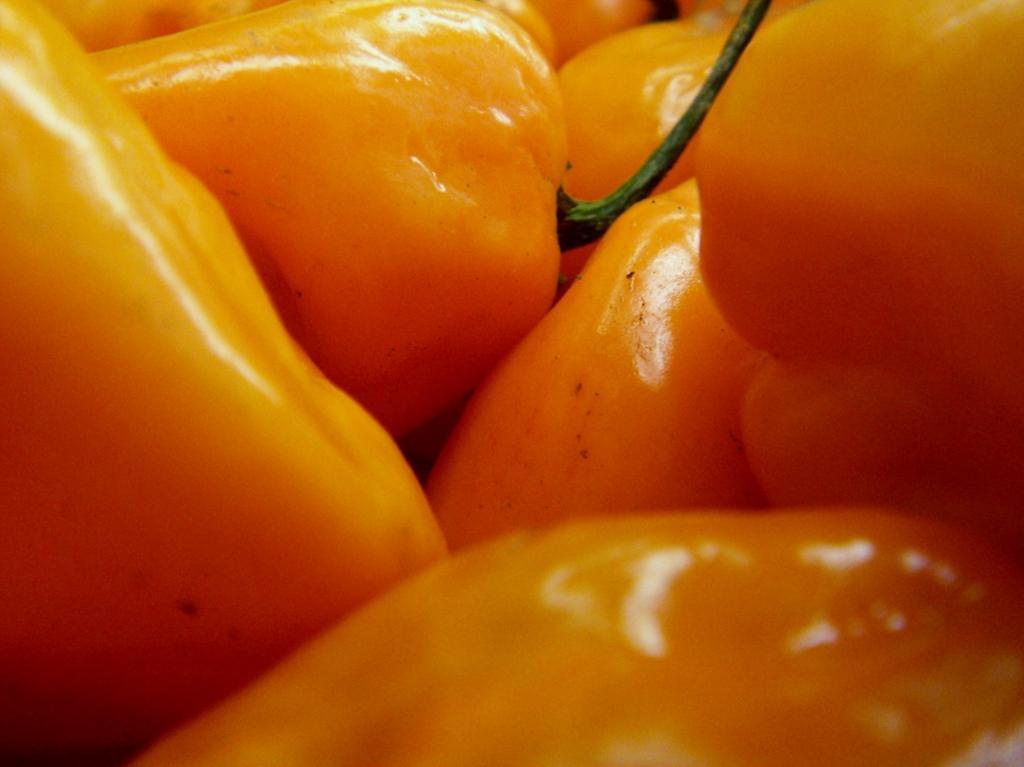Could you give a brief overview of what you see in this image? In the image we can see there are many yellow peppers. 